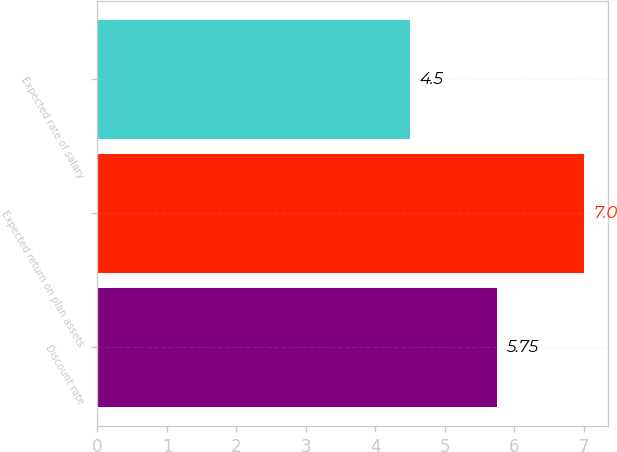Convert chart to OTSL. <chart><loc_0><loc_0><loc_500><loc_500><bar_chart><fcel>Discount rate<fcel>Expected return on plan assets<fcel>Expected rate of salary<nl><fcel>5.75<fcel>7<fcel>4.5<nl></chart> 